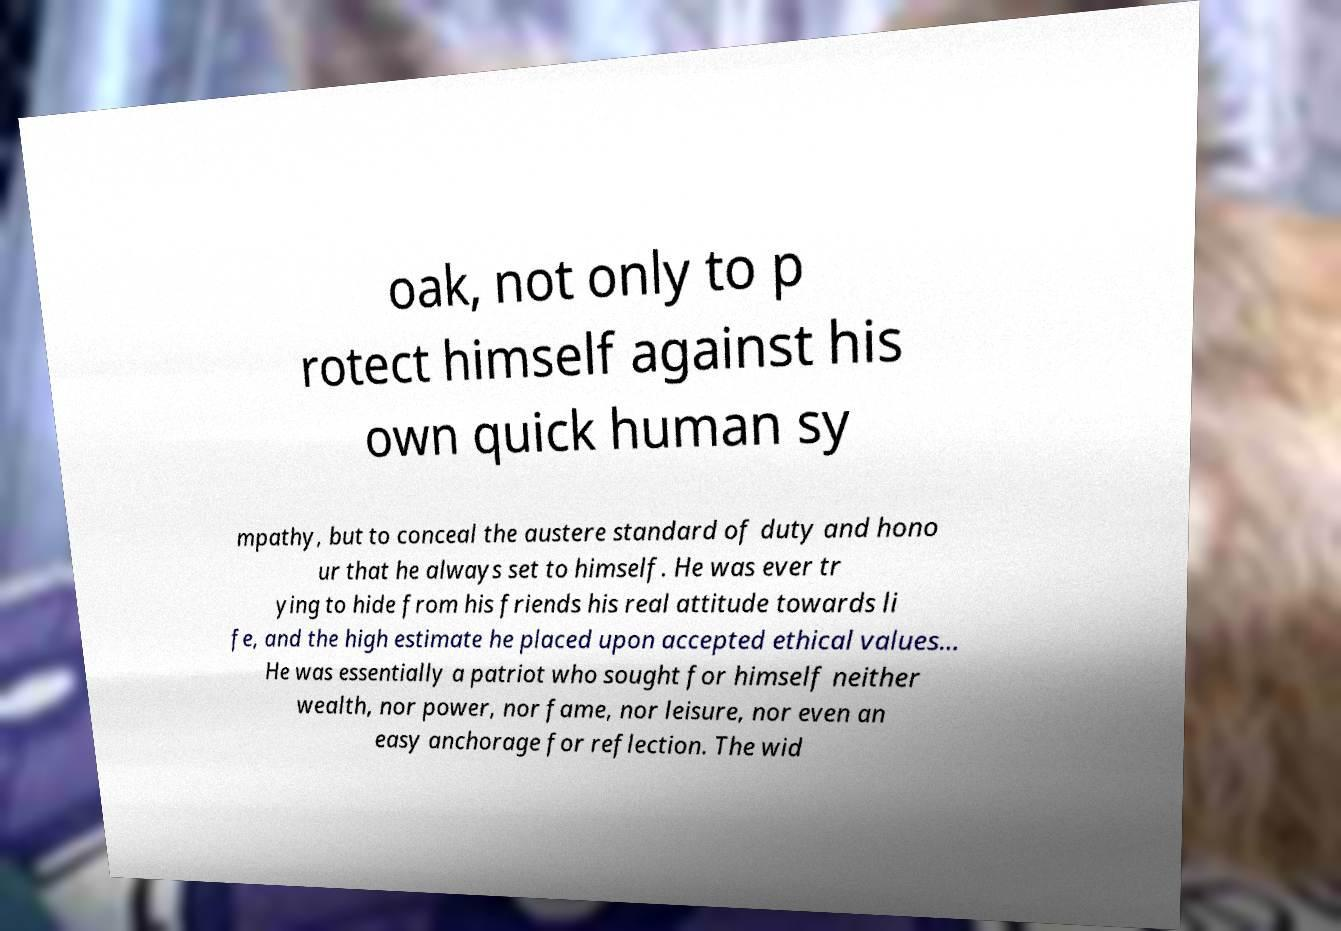What messages or text are displayed in this image? I need them in a readable, typed format. oak, not only to p rotect himself against his own quick human sy mpathy, but to conceal the austere standard of duty and hono ur that he always set to himself. He was ever tr ying to hide from his friends his real attitude towards li fe, and the high estimate he placed upon accepted ethical values... He was essentially a patriot who sought for himself neither wealth, nor power, nor fame, nor leisure, nor even an easy anchorage for reflection. The wid 